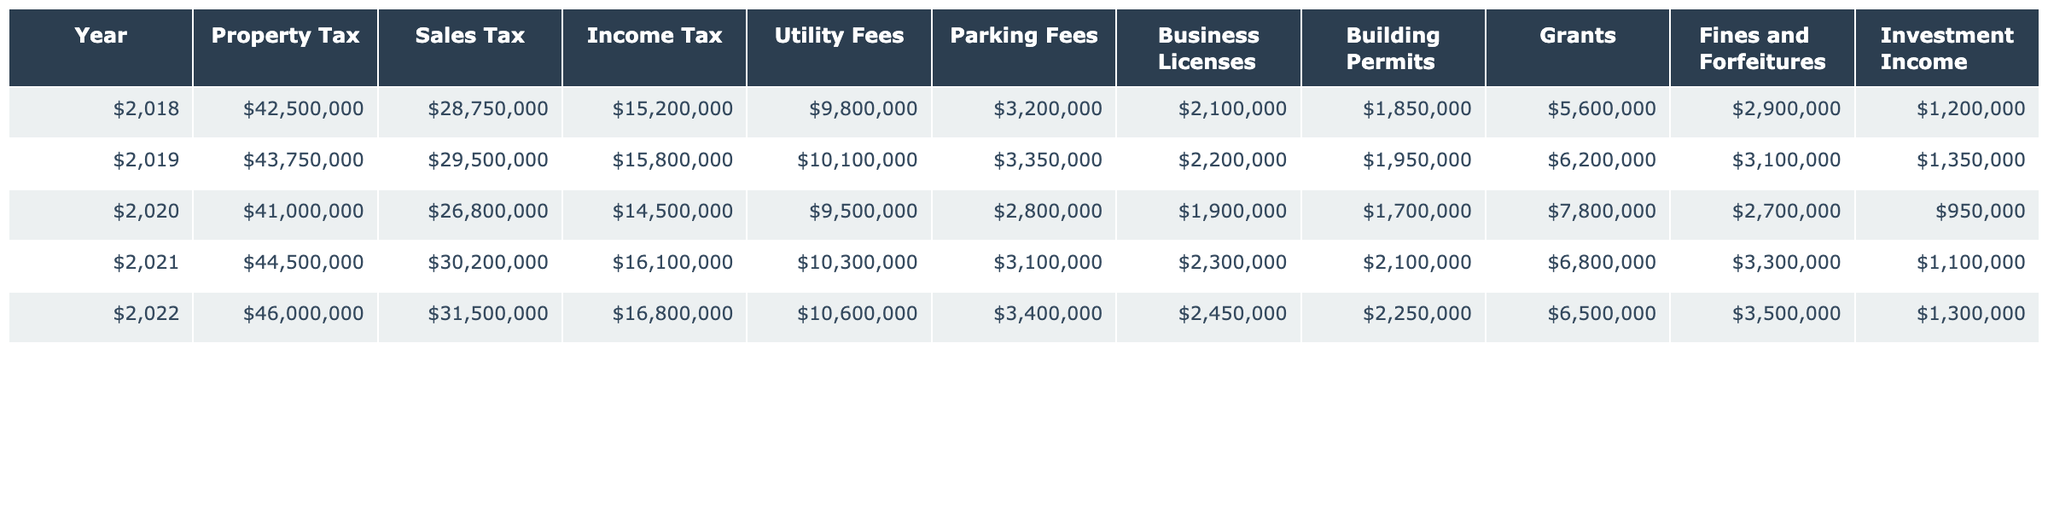What was the highest revenue source in 2021? In 2021, the revenue sources were analyzed across all categories, and Property Tax at $44,500,000 was the highest among them.
Answer: Property Tax Which year had the lowest income from Utility Fees? Reviewing the table, the year 2020 shows the lowest value for Utility Fees at $9,500,000.
Answer: 2020 What is the total revenue from Sales Tax over the five years? To find the total revenue from Sales Tax, we sum the amounts for each year: 28,750,000 + 29,500,000 + 26,800,000 + 30,200,000 + 31,500,000 = 146,750,000.
Answer: 146,750,000 Did the amount from Grants increase or decrease from 2018 to 2022? The data shows that Grants increased from $5,600,000 in 2018 to $6,500,000 in 2022, indicating an increase.
Answer: Increase What was the average revenue from Fines and Forfeitures over the five years? The average is calculated by summing the values: (2,900,000 + 3,100,000 + 2,700,000 + 3,300,000 + 3,500,000) = 15,500,000, then dividing by 5 gives 3,100,000.
Answer: 3,100,000 Which year had the highest total revenue and what was that amount? To find the year with the highest total revenue, we must calculate the sum of all revenue sources for each year and find the maximum. Year 2022 totals $106,500,000, which is the highest.
Answer: 2022, $106,500,000 Is the revenue from Business Licenses higher in 2022 or 2020? Comparing the values for Business Licenses, 2022 has $2,450,000 while 2020 has $1,900,000, so 2022 is higher.
Answer: 2022 What percentage of the total revenue in 2019 was generated from Property Tax? The total revenue for 2019 is calculated by summing all sources, which gives $143,500,000. Property Tax is $43,750,000, hence the percentage is (43,750,000 / 143,500,000) * 100 = 30.5%.
Answer: 30.5% How much did Parking Fees contribute to the total revenue in 2021 compared to 2020? In 2021, Parking Fees were $3,100,000 and in 2020 they were $2,800,000. The contribution in 2021 is higher by $300,000 when compared to 2020.
Answer: $300,000 increase What was the change in total revenue from all sources between 2018 and 2022? The total revenue for 2018 is $93,500,000 and for 2022 it is $106,500,000. The change is $106,500,000 - $93,500,000 = $13,000,000 increase.
Answer: $13,000,000 increase 